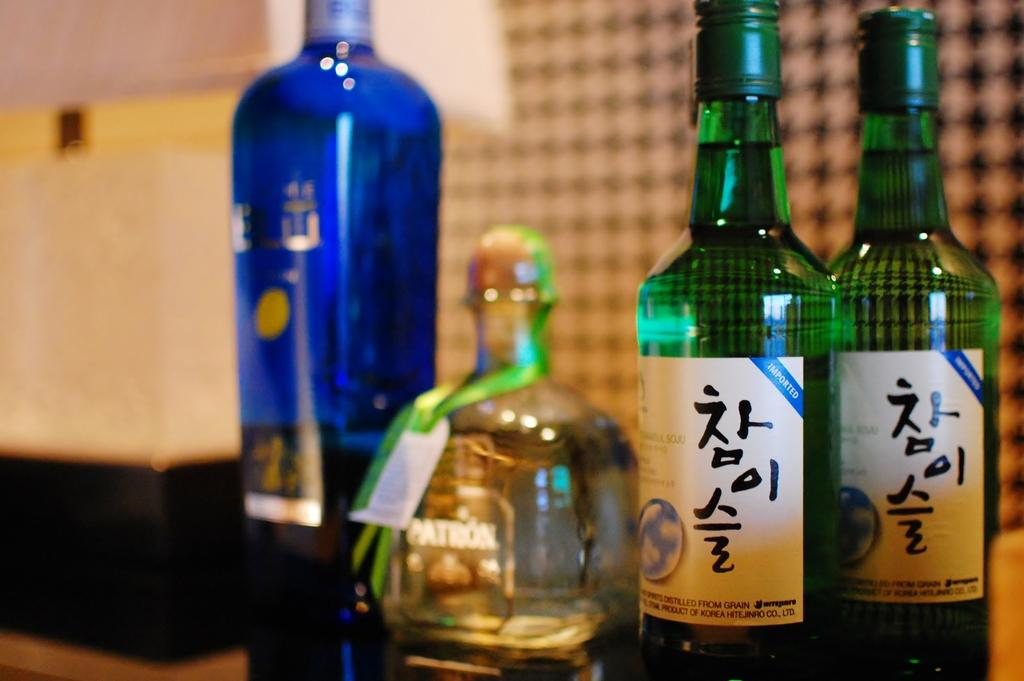<image>
Present a compact description of the photo's key features. A bottle of Patron tequila is flanked by two tall green bottles and a blue bottle that are also full. 